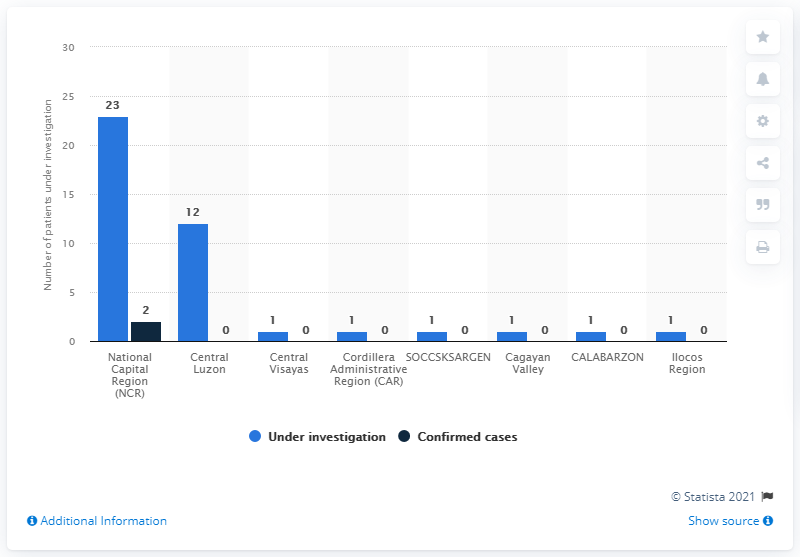Draw attention to some important aspects in this diagram. The National Capital Region (NCR) in the Philippines is the only region where a visible black bar can be seen in the graph. The average number of under investigation cases in the two largest regions is 17.5. As of today, 23 patients are currently under investigation for COVID-19. 